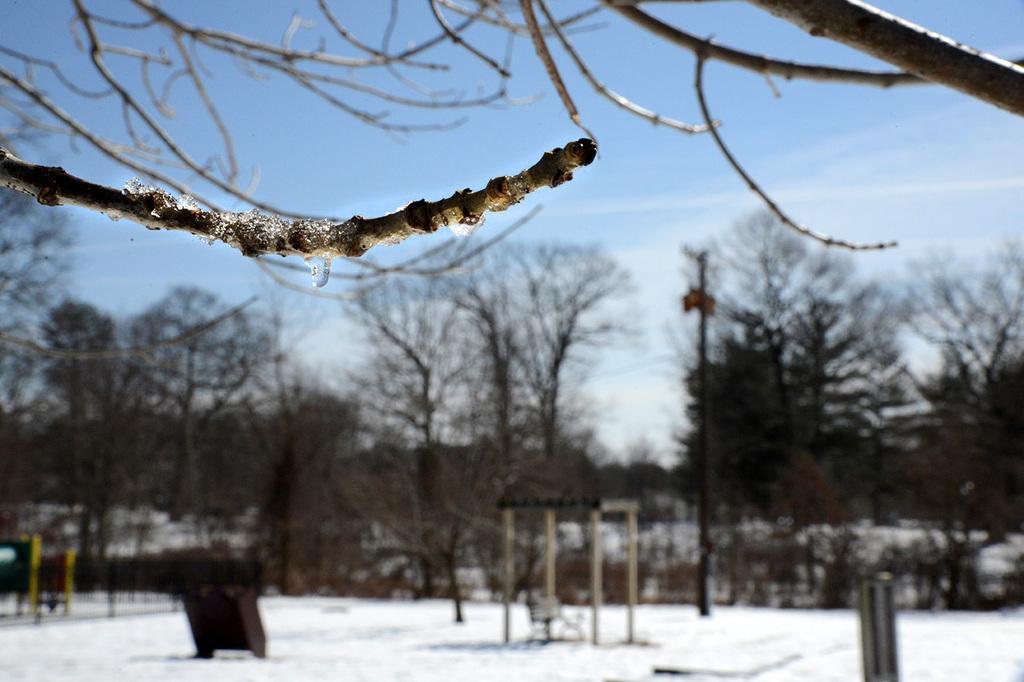How would you summarize this image in a sentence or two? In this picture we can see snow at the bottom, there is a pole in the middle, we can see trees in the background, there is the sky at the top of the picture, we can see branches of a tree in the front. 